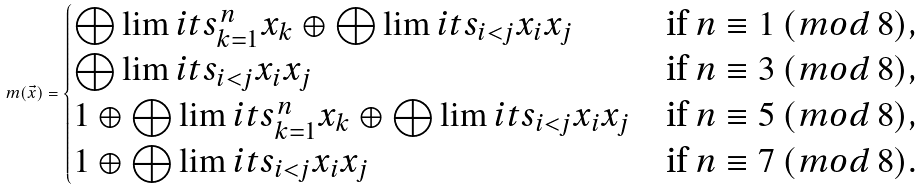<formula> <loc_0><loc_0><loc_500><loc_500>m ( \vec { x } ) = \begin{cases} \bigoplus \lim i t s ^ { n } _ { k = 1 } x _ { k } \oplus \bigoplus \lim i t s _ { i < j } x _ { i } x _ { j } & \text {if} \ n \equiv 1 \ ( m o d \ 8 ) , \\ \bigoplus \lim i t s _ { i < j } x _ { i } x _ { j } & \text {if} \ n \equiv 3 \ ( m o d \ 8 ) , \\ 1 \oplus \bigoplus \lim i t s ^ { n } _ { k = 1 } x _ { k } \oplus \bigoplus \lim i t s _ { i < j } x _ { i } x _ { j } & \text {if} \ n \equiv 5 \ ( m o d \ 8 ) , \\ 1 \oplus \bigoplus \lim i t s _ { i < j } x _ { i } x _ { j } & \text {if} \ n \equiv 7 \ ( m o d \ 8 ) . \end{cases}</formula> 